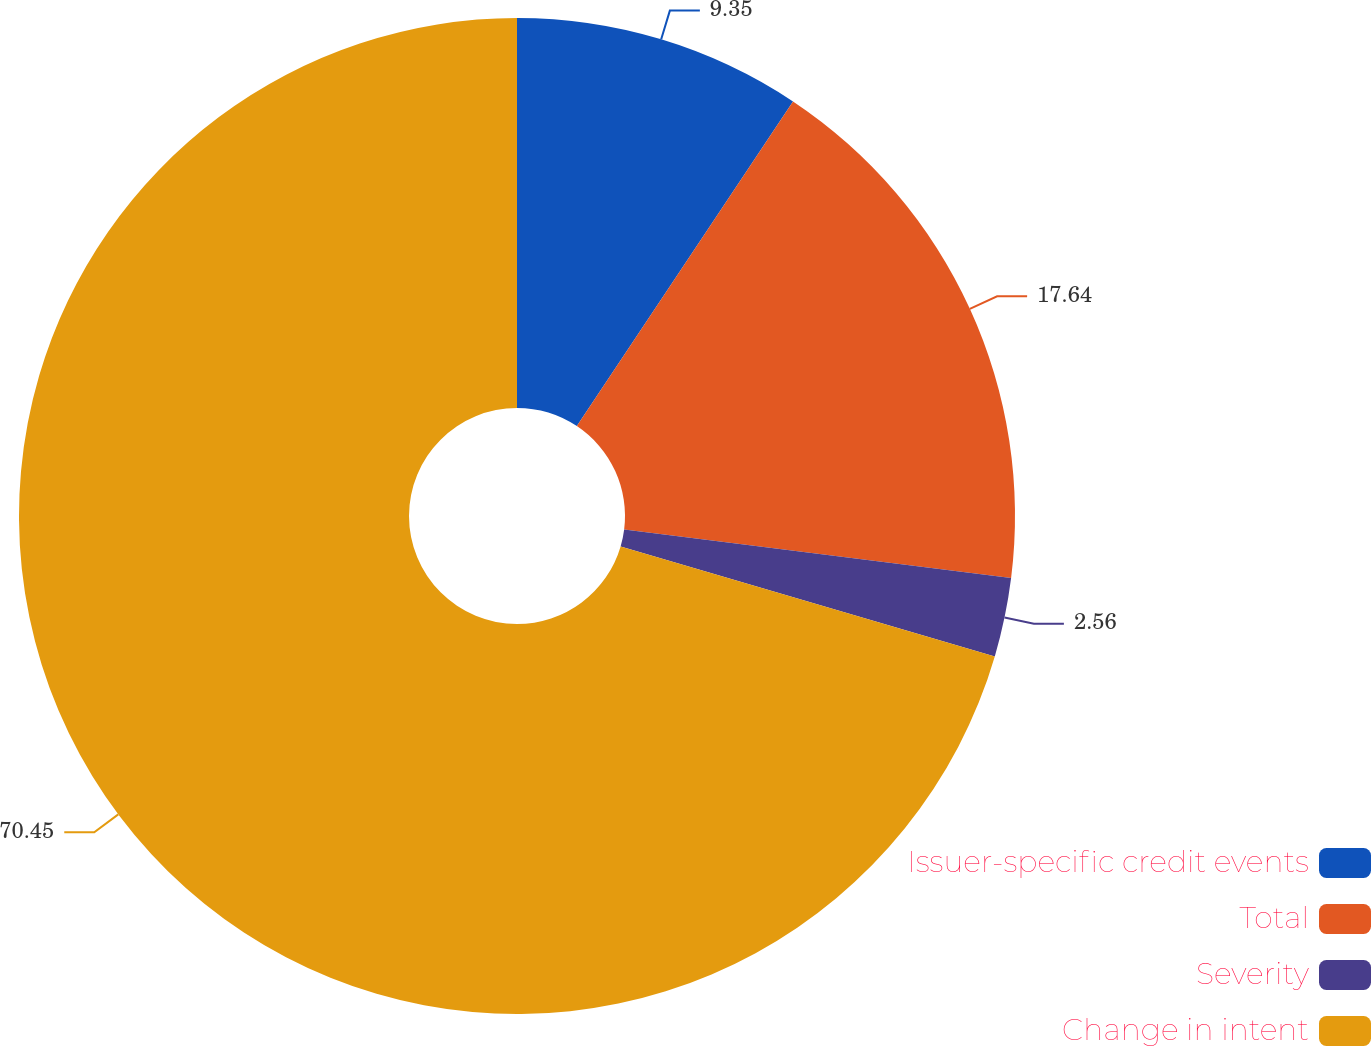<chart> <loc_0><loc_0><loc_500><loc_500><pie_chart><fcel>Issuer-specific credit events<fcel>Total<fcel>Severity<fcel>Change in intent<nl><fcel>9.35%<fcel>17.64%<fcel>2.56%<fcel>70.45%<nl></chart> 